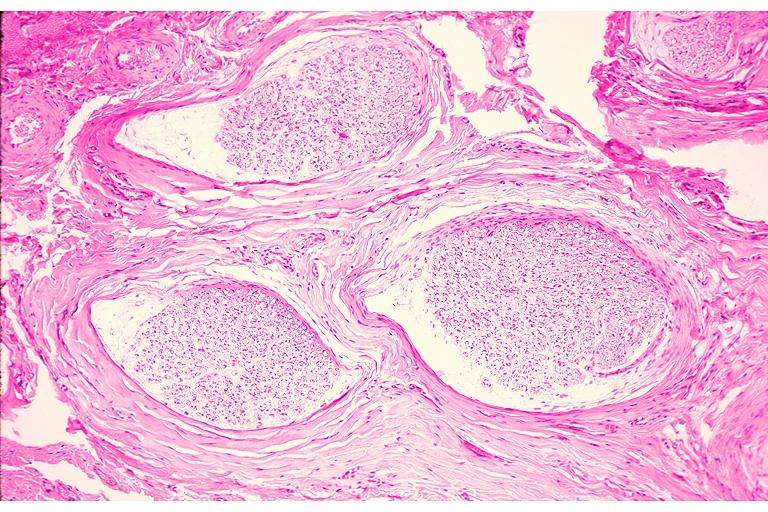does mucoepidermoid carcinoma show traumatic neuroma?
Answer the question using a single word or phrase. No 